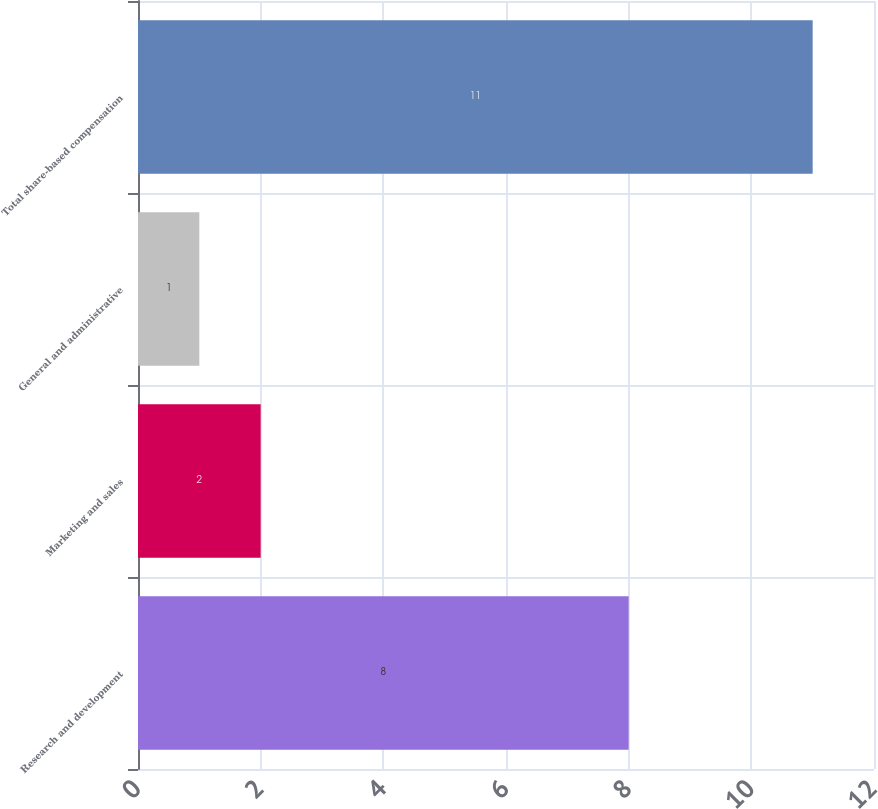Convert chart to OTSL. <chart><loc_0><loc_0><loc_500><loc_500><bar_chart><fcel>Research and development<fcel>Marketing and sales<fcel>General and administrative<fcel>Total share-based compensation<nl><fcel>8<fcel>2<fcel>1<fcel>11<nl></chart> 